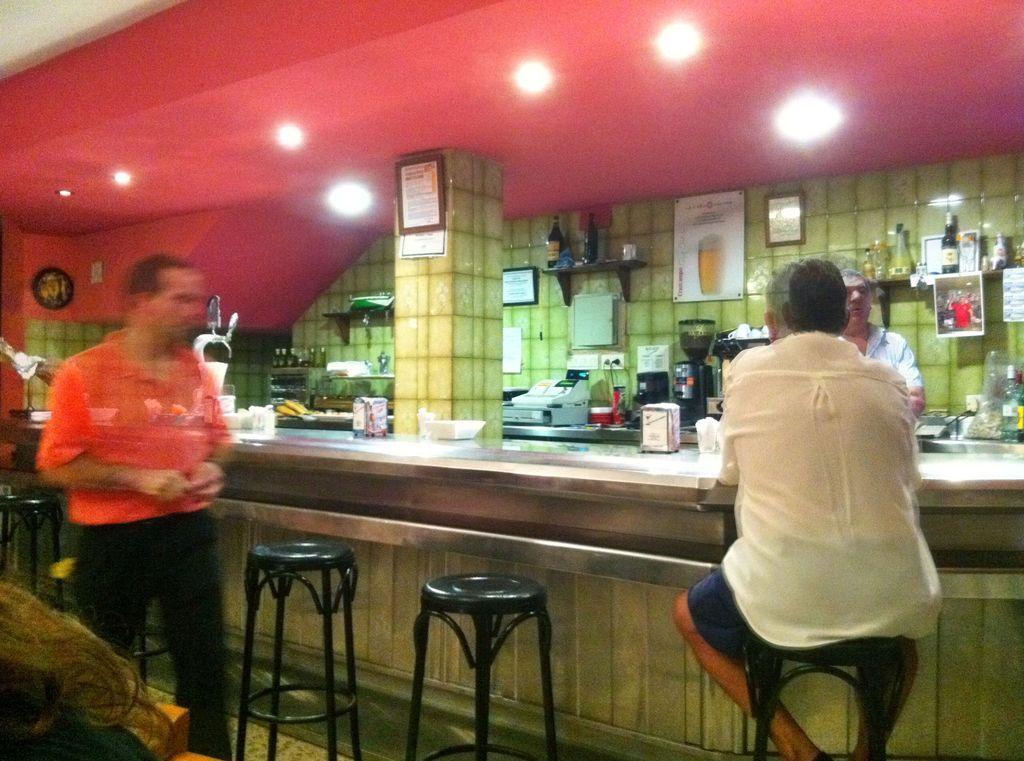Could you give a brief overview of what you see in this image? In the image we can see there are people who are standing and a man is sitting on chair. 